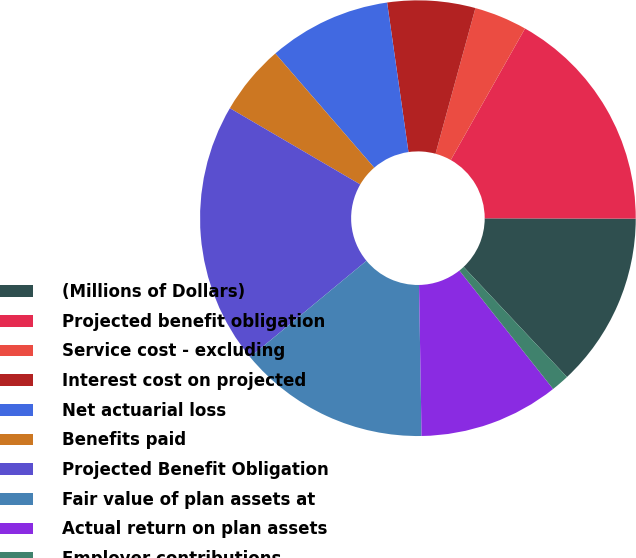<chart> <loc_0><loc_0><loc_500><loc_500><pie_chart><fcel>(Millions of Dollars)<fcel>Projected benefit obligation<fcel>Service cost - excluding<fcel>Interest cost on projected<fcel>Net actuarial loss<fcel>Benefits paid<fcel>Projected Benefit Obligation<fcel>Fair value of plan assets at<fcel>Actual return on plan assets<fcel>Employer contributions<nl><fcel>12.97%<fcel>16.85%<fcel>3.93%<fcel>6.51%<fcel>9.1%<fcel>5.22%<fcel>19.43%<fcel>14.26%<fcel>10.39%<fcel>1.34%<nl></chart> 